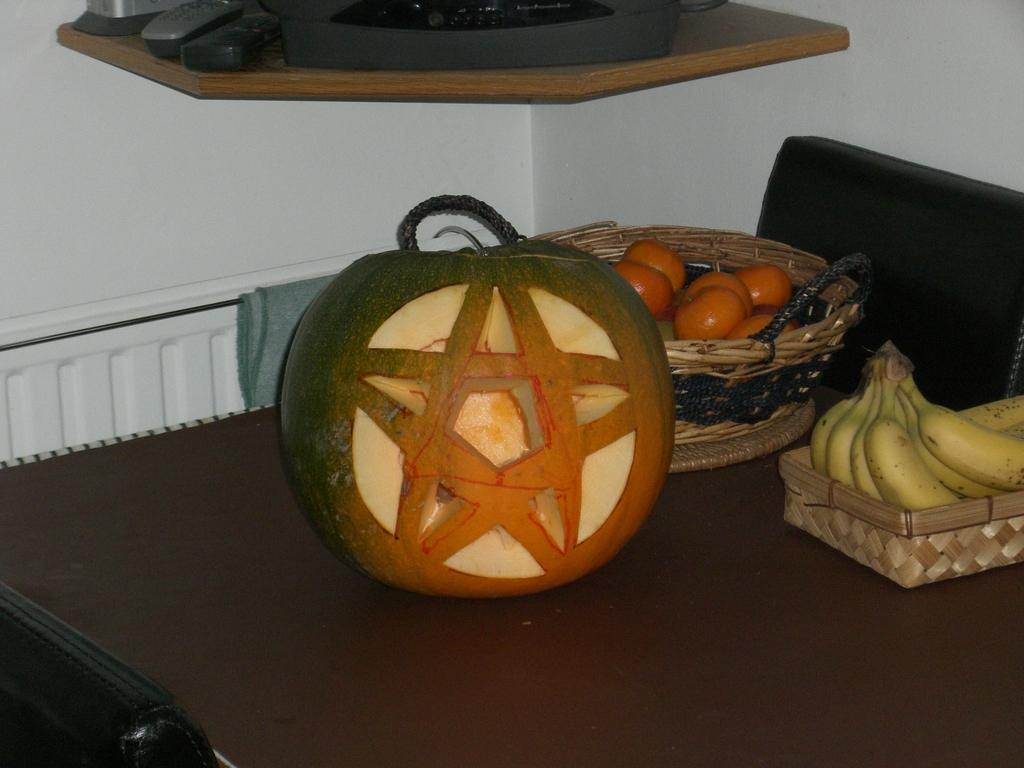Please provide a concise description of this image. In this picture, there is a table which is in black color, on that table there is a yellow color box, in that there are some bananas kept which are in yellow color, there are some fruits kept on the table, in the background there is a white color wall. 